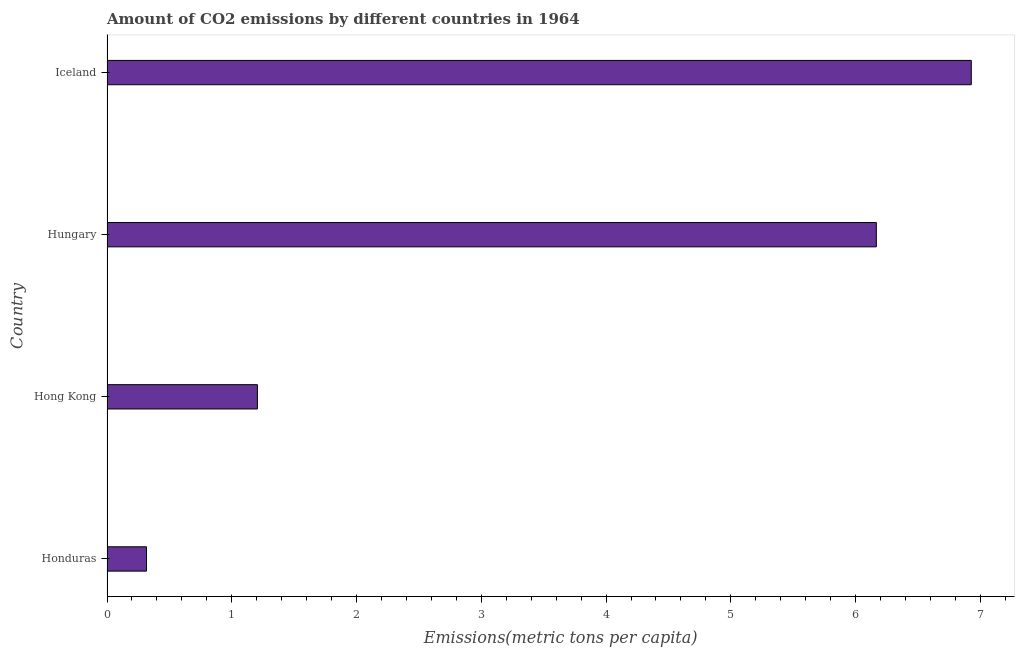Does the graph contain any zero values?
Ensure brevity in your answer.  No. What is the title of the graph?
Offer a very short reply. Amount of CO2 emissions by different countries in 1964. What is the label or title of the X-axis?
Your answer should be very brief. Emissions(metric tons per capita). What is the amount of co2 emissions in Hungary?
Make the answer very short. 6.17. Across all countries, what is the maximum amount of co2 emissions?
Provide a succinct answer. 6.93. Across all countries, what is the minimum amount of co2 emissions?
Make the answer very short. 0.32. In which country was the amount of co2 emissions minimum?
Provide a succinct answer. Honduras. What is the sum of the amount of co2 emissions?
Offer a terse response. 14.62. What is the difference between the amount of co2 emissions in Honduras and Hungary?
Ensure brevity in your answer.  -5.85. What is the average amount of co2 emissions per country?
Give a very brief answer. 3.65. What is the median amount of co2 emissions?
Provide a succinct answer. 3.69. In how many countries, is the amount of co2 emissions greater than 4.6 metric tons per capita?
Ensure brevity in your answer.  2. What is the ratio of the amount of co2 emissions in Hong Kong to that in Iceland?
Your answer should be very brief. 0.17. Is the difference between the amount of co2 emissions in Honduras and Iceland greater than the difference between any two countries?
Offer a very short reply. Yes. What is the difference between the highest and the second highest amount of co2 emissions?
Provide a succinct answer. 0.76. What is the difference between the highest and the lowest amount of co2 emissions?
Offer a very short reply. 6.61. In how many countries, is the amount of co2 emissions greater than the average amount of co2 emissions taken over all countries?
Your answer should be compact. 2. Are all the bars in the graph horizontal?
Your response must be concise. Yes. How many countries are there in the graph?
Give a very brief answer. 4. What is the difference between two consecutive major ticks on the X-axis?
Offer a very short reply. 1. Are the values on the major ticks of X-axis written in scientific E-notation?
Offer a terse response. No. What is the Emissions(metric tons per capita) of Honduras?
Make the answer very short. 0.32. What is the Emissions(metric tons per capita) of Hong Kong?
Provide a succinct answer. 1.21. What is the Emissions(metric tons per capita) in Hungary?
Make the answer very short. 6.17. What is the Emissions(metric tons per capita) of Iceland?
Make the answer very short. 6.93. What is the difference between the Emissions(metric tons per capita) in Honduras and Hong Kong?
Your response must be concise. -0.89. What is the difference between the Emissions(metric tons per capita) in Honduras and Hungary?
Offer a very short reply. -5.85. What is the difference between the Emissions(metric tons per capita) in Honduras and Iceland?
Provide a short and direct response. -6.61. What is the difference between the Emissions(metric tons per capita) in Hong Kong and Hungary?
Your answer should be very brief. -4.96. What is the difference between the Emissions(metric tons per capita) in Hong Kong and Iceland?
Your answer should be compact. -5.72. What is the difference between the Emissions(metric tons per capita) in Hungary and Iceland?
Ensure brevity in your answer.  -0.76. What is the ratio of the Emissions(metric tons per capita) in Honduras to that in Hong Kong?
Provide a short and direct response. 0.26. What is the ratio of the Emissions(metric tons per capita) in Honduras to that in Hungary?
Offer a terse response. 0.05. What is the ratio of the Emissions(metric tons per capita) in Honduras to that in Iceland?
Offer a very short reply. 0.05. What is the ratio of the Emissions(metric tons per capita) in Hong Kong to that in Hungary?
Keep it short and to the point. 0.2. What is the ratio of the Emissions(metric tons per capita) in Hong Kong to that in Iceland?
Keep it short and to the point. 0.17. What is the ratio of the Emissions(metric tons per capita) in Hungary to that in Iceland?
Your response must be concise. 0.89. 